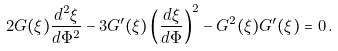<formula> <loc_0><loc_0><loc_500><loc_500>2 G ( \xi ) \frac { d ^ { 2 } \xi } { d \Phi ^ { 2 } } - 3 G ^ { \prime } ( \xi ) \left ( \frac { d \xi } { d \Phi } \right ) ^ { 2 } - G ^ { 2 } ( \xi ) G ^ { \prime } ( \xi ) = 0 \, .</formula> 